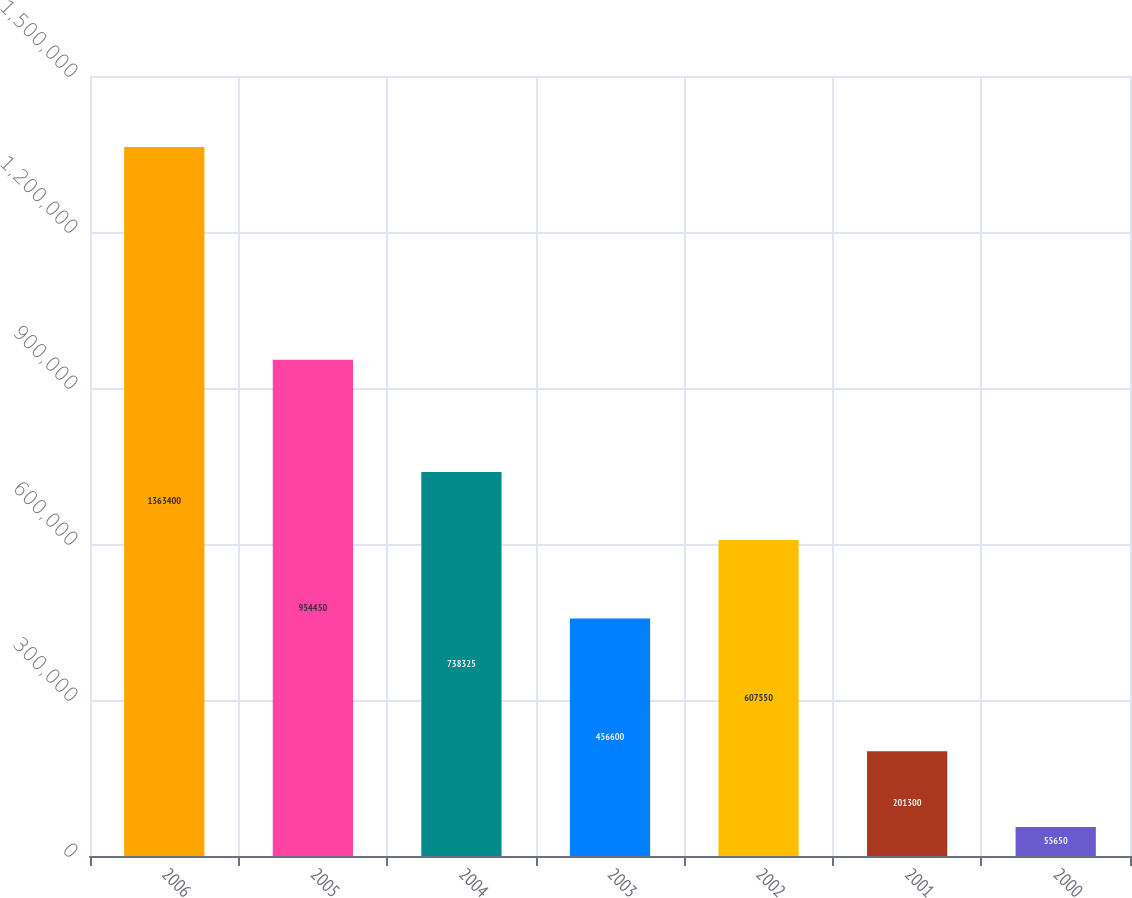Convert chart. <chart><loc_0><loc_0><loc_500><loc_500><bar_chart><fcel>2006<fcel>2005<fcel>2004<fcel>2003<fcel>2002<fcel>2001<fcel>2000<nl><fcel>1.3634e+06<fcel>954450<fcel>738325<fcel>456600<fcel>607550<fcel>201300<fcel>55650<nl></chart> 